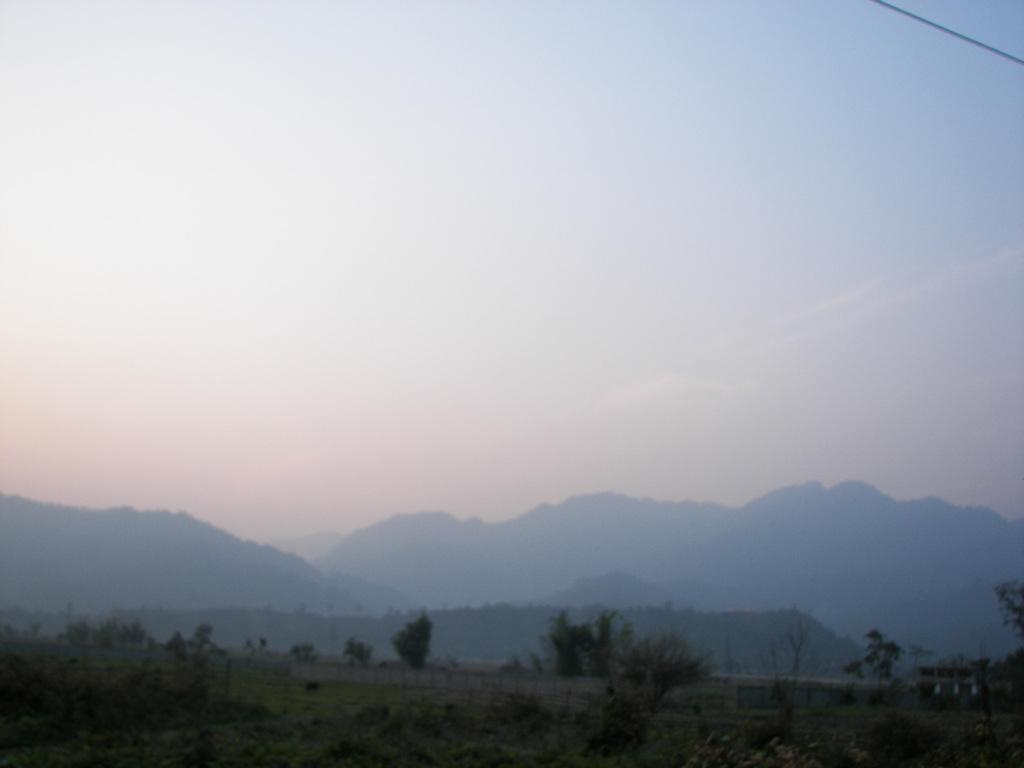What type of vegetation can be seen in the image? There are plants and trees in the image. What type of landscape feature is visible in the image? There are hills visible in the image. What is visible at the top of the image? The sky is visible at the top of the image. Where is the receipt for the party located in the image? There is no party or receipt present in the image. How does the dust affect the plants in the image? There is no dust present in the image, so its effect on the plants cannot be determined. 